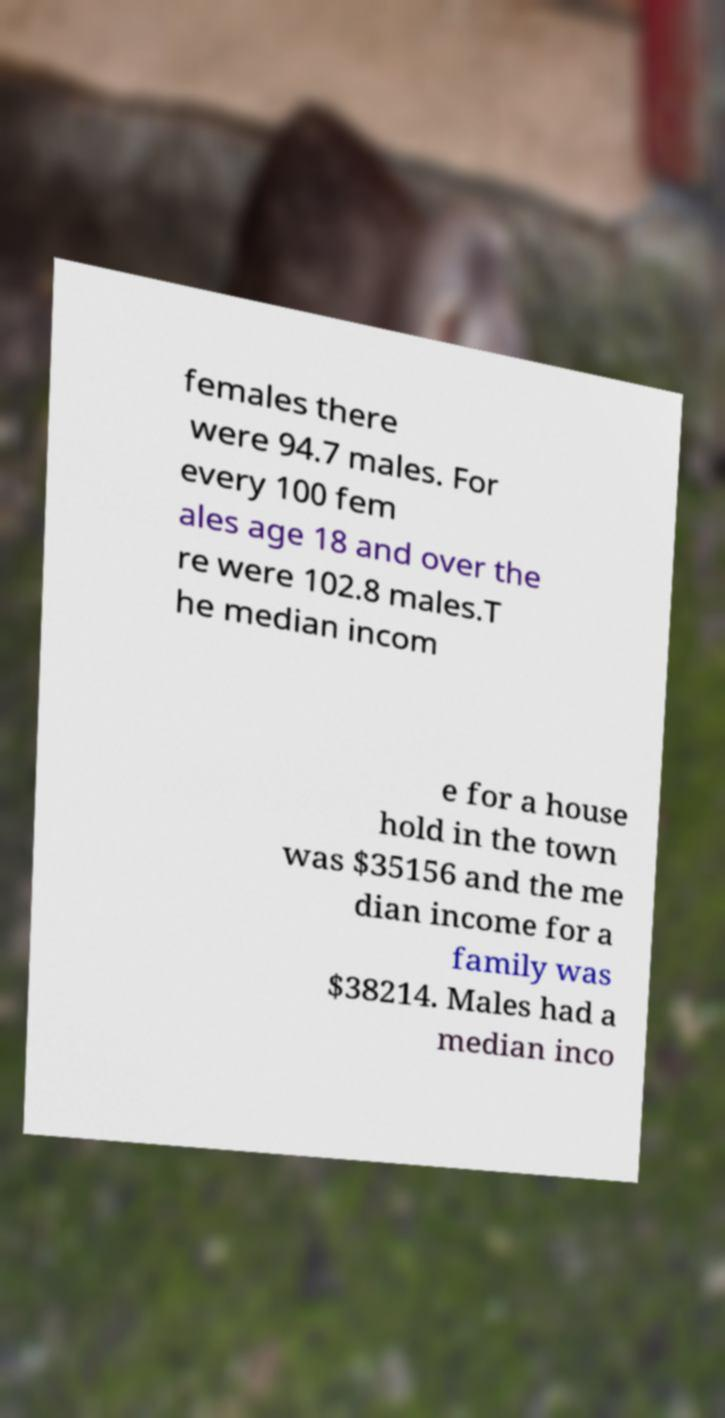Can you accurately transcribe the text from the provided image for me? females there were 94.7 males. For every 100 fem ales age 18 and over the re were 102.8 males.T he median incom e for a house hold in the town was $35156 and the me dian income for a family was $38214. Males had a median inco 